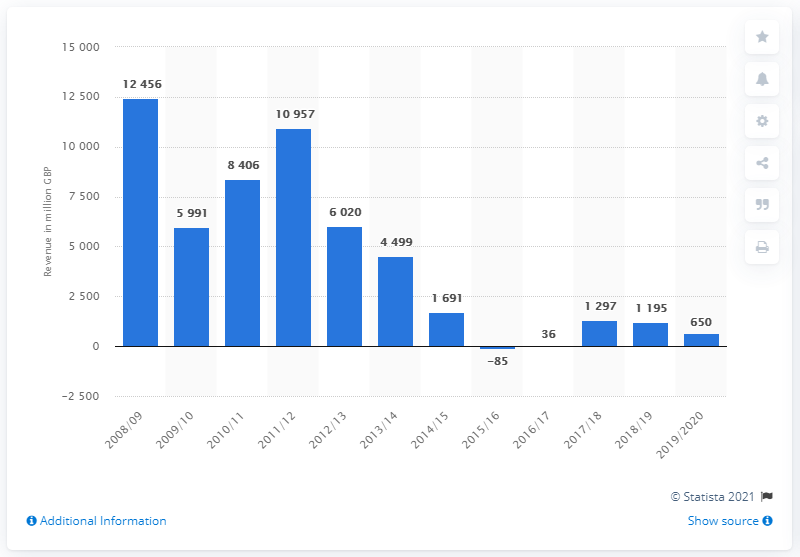Draw attention to some important aspects in this diagram. In the 2019/20 fiscal year, the North Sea revenue was 650... 